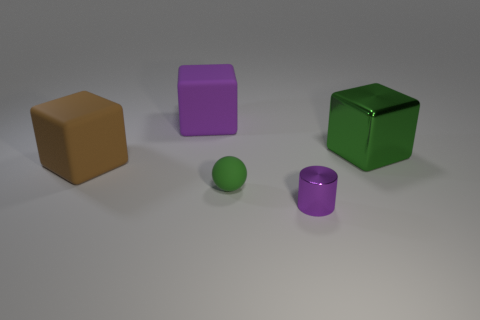How would you categorize these objects by size? Looking at the image, the objects can be categorized by size into two groups. The first group includes the larger cubes—one brown, one purple, and one green. The second group contains the smaller objects: a small purple cylinder and a small green sphere. 